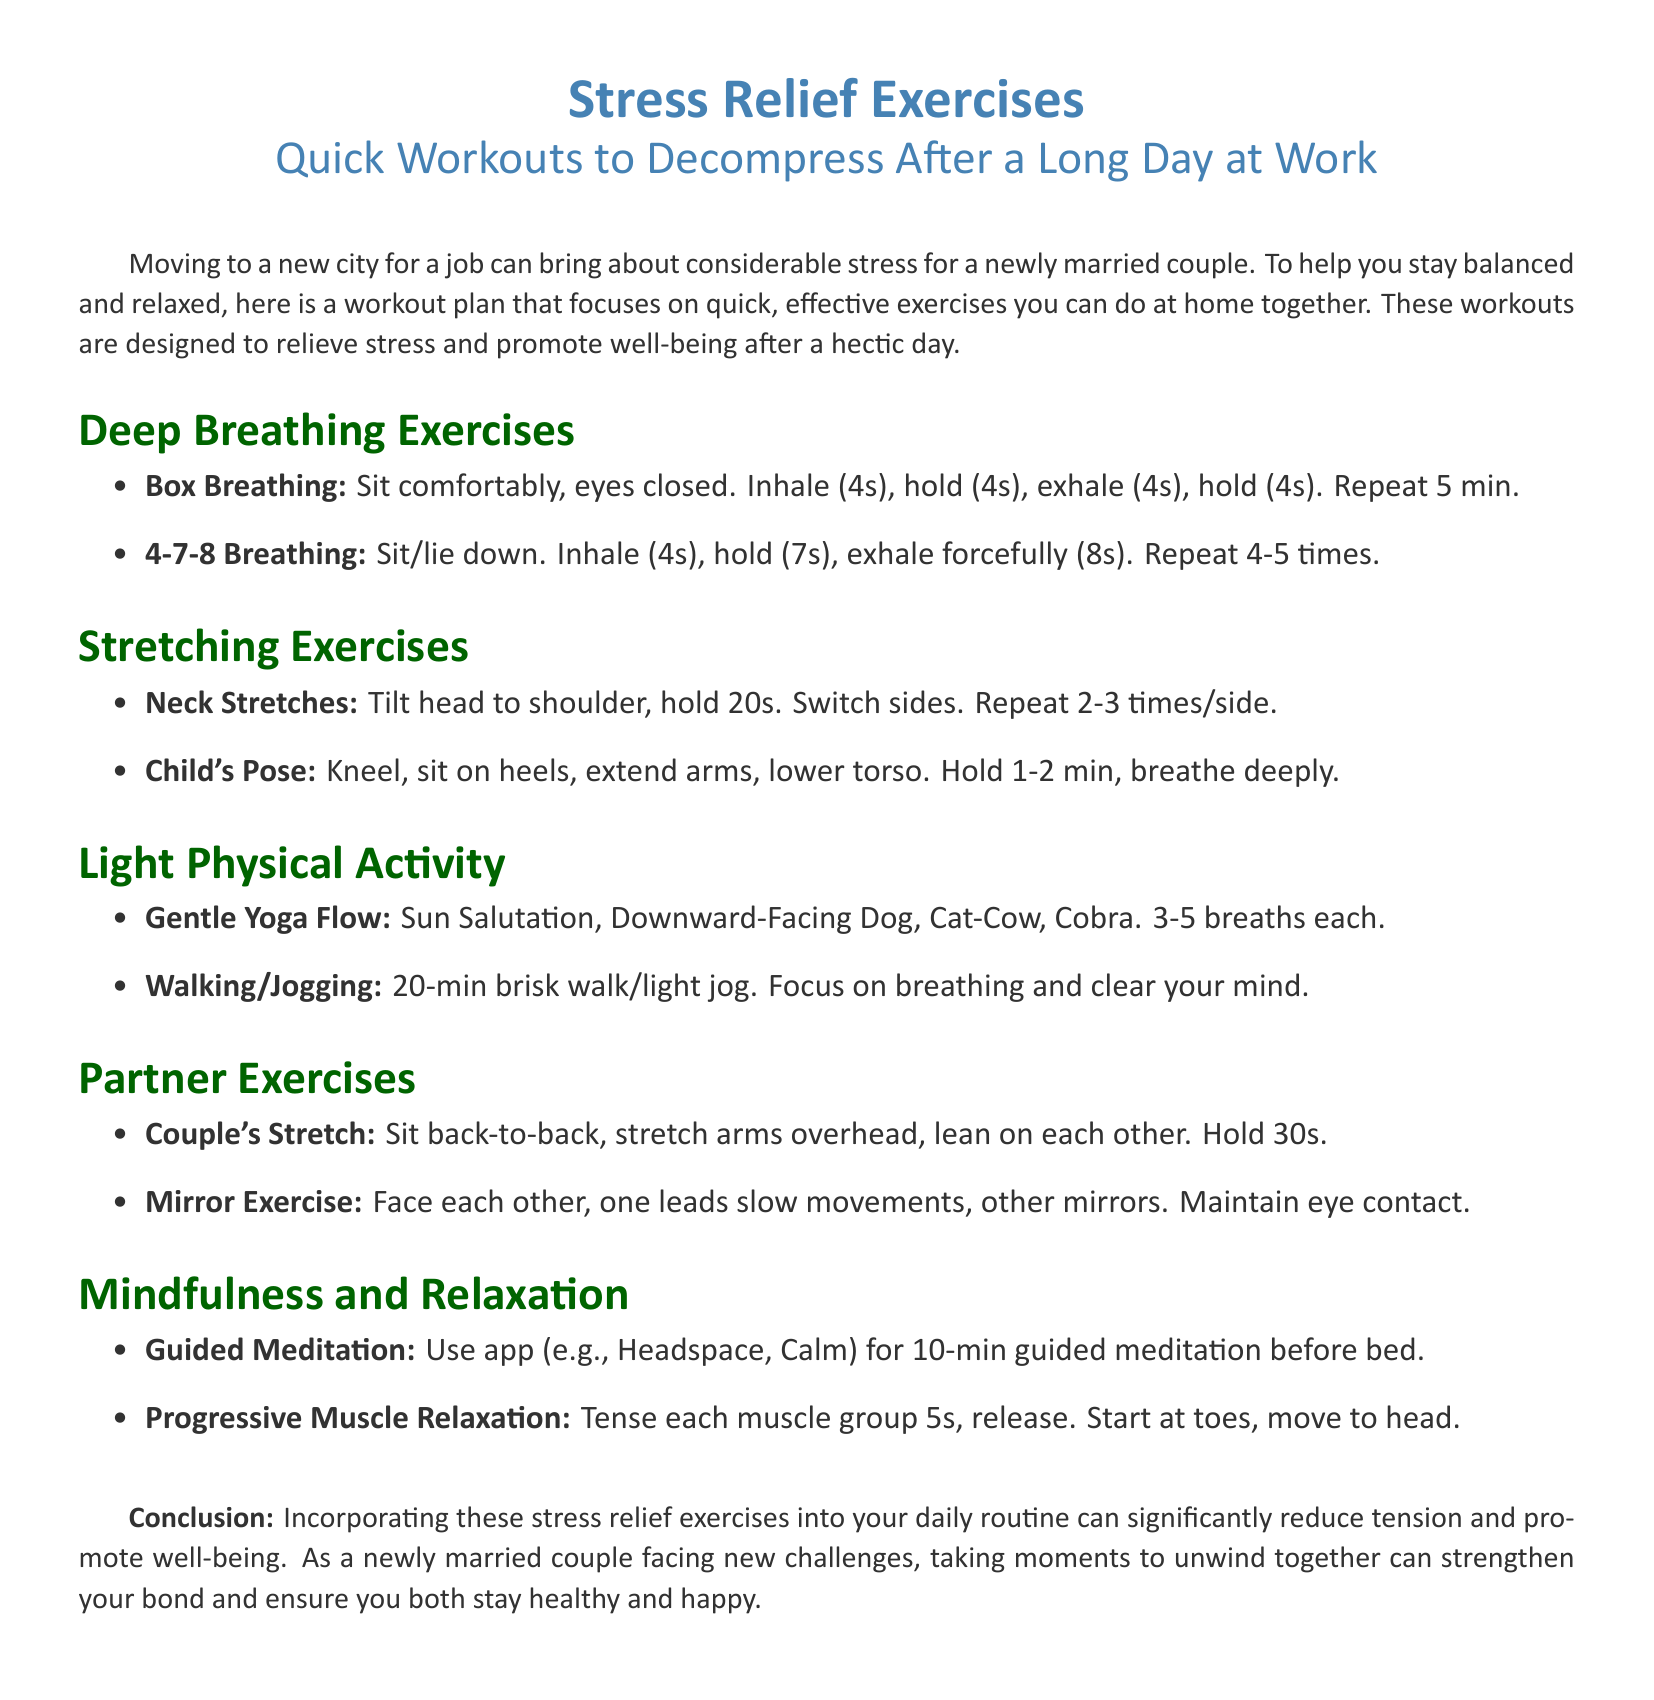What is the title of the document? The title of the document is explicitly mentioned at the top as "Stress Relief Exercises".
Answer: Stress Relief Exercises What is the duration of the Box Breathing exercise? The document specifies that Box Breathing should be repeated for 5 minutes.
Answer: 5 min How long should you hold the Child's Pose? The document states that you should hold Child's Pose for 1-2 minutes.
Answer: 1-2 min How many breaths should you take in each Gentle Yoga Flow pose? The document indicates that you should take 3-5 breaths in each pose.
Answer: 3-5 breaths What is the main focus during the 20-min brisk walk/light jog? The document mentions the focus should be on breathing and clearing your mind.
Answer: Breathing and clear your mind What do the Partner Exercises aim to promote? The document suggests that these exercises are intended to strengthen the bond between the couple.
Answer: Strengthen your bond What app is suggested for guided meditation? The document recommends using apps like Headspace or Calm for guided meditation.
Answer: Headspace, Calm What is the first step in Progressive Muscle Relaxation? The document indicates to start at the toes for this relaxation technique.
Answer: Toes How many times should you switch sides for neck stretches? The document describes repeating neck stretches 2-3 times on each side.
Answer: 2-3 times 